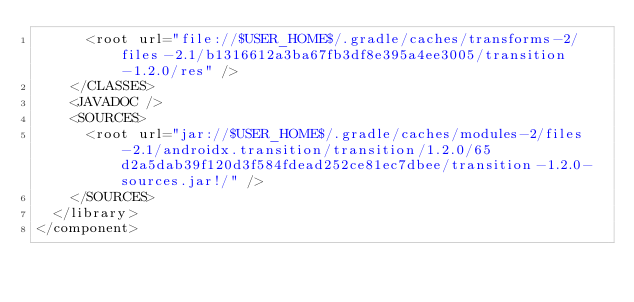<code> <loc_0><loc_0><loc_500><loc_500><_XML_>      <root url="file://$USER_HOME$/.gradle/caches/transforms-2/files-2.1/b1316612a3ba67fb3df8e395a4ee3005/transition-1.2.0/res" />
    </CLASSES>
    <JAVADOC />
    <SOURCES>
      <root url="jar://$USER_HOME$/.gradle/caches/modules-2/files-2.1/androidx.transition/transition/1.2.0/65d2a5dab39f120d3f584fdead252ce81ec7dbee/transition-1.2.0-sources.jar!/" />
    </SOURCES>
  </library>
</component></code> 